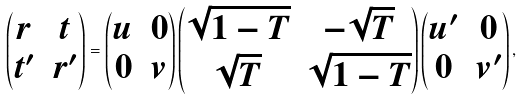<formula> <loc_0><loc_0><loc_500><loc_500>\begin{pmatrix} r & t \\ t ^ { \prime } & r ^ { \prime } \end{pmatrix} = \begin{pmatrix} u & 0 \\ 0 & v \end{pmatrix} \begin{pmatrix} \sqrt { 1 - T } & - \sqrt { T } \\ \sqrt { T } & \sqrt { 1 - T } \end{pmatrix} \begin{pmatrix} u ^ { \prime } & 0 \\ 0 & v ^ { \prime } \end{pmatrix} ,</formula> 